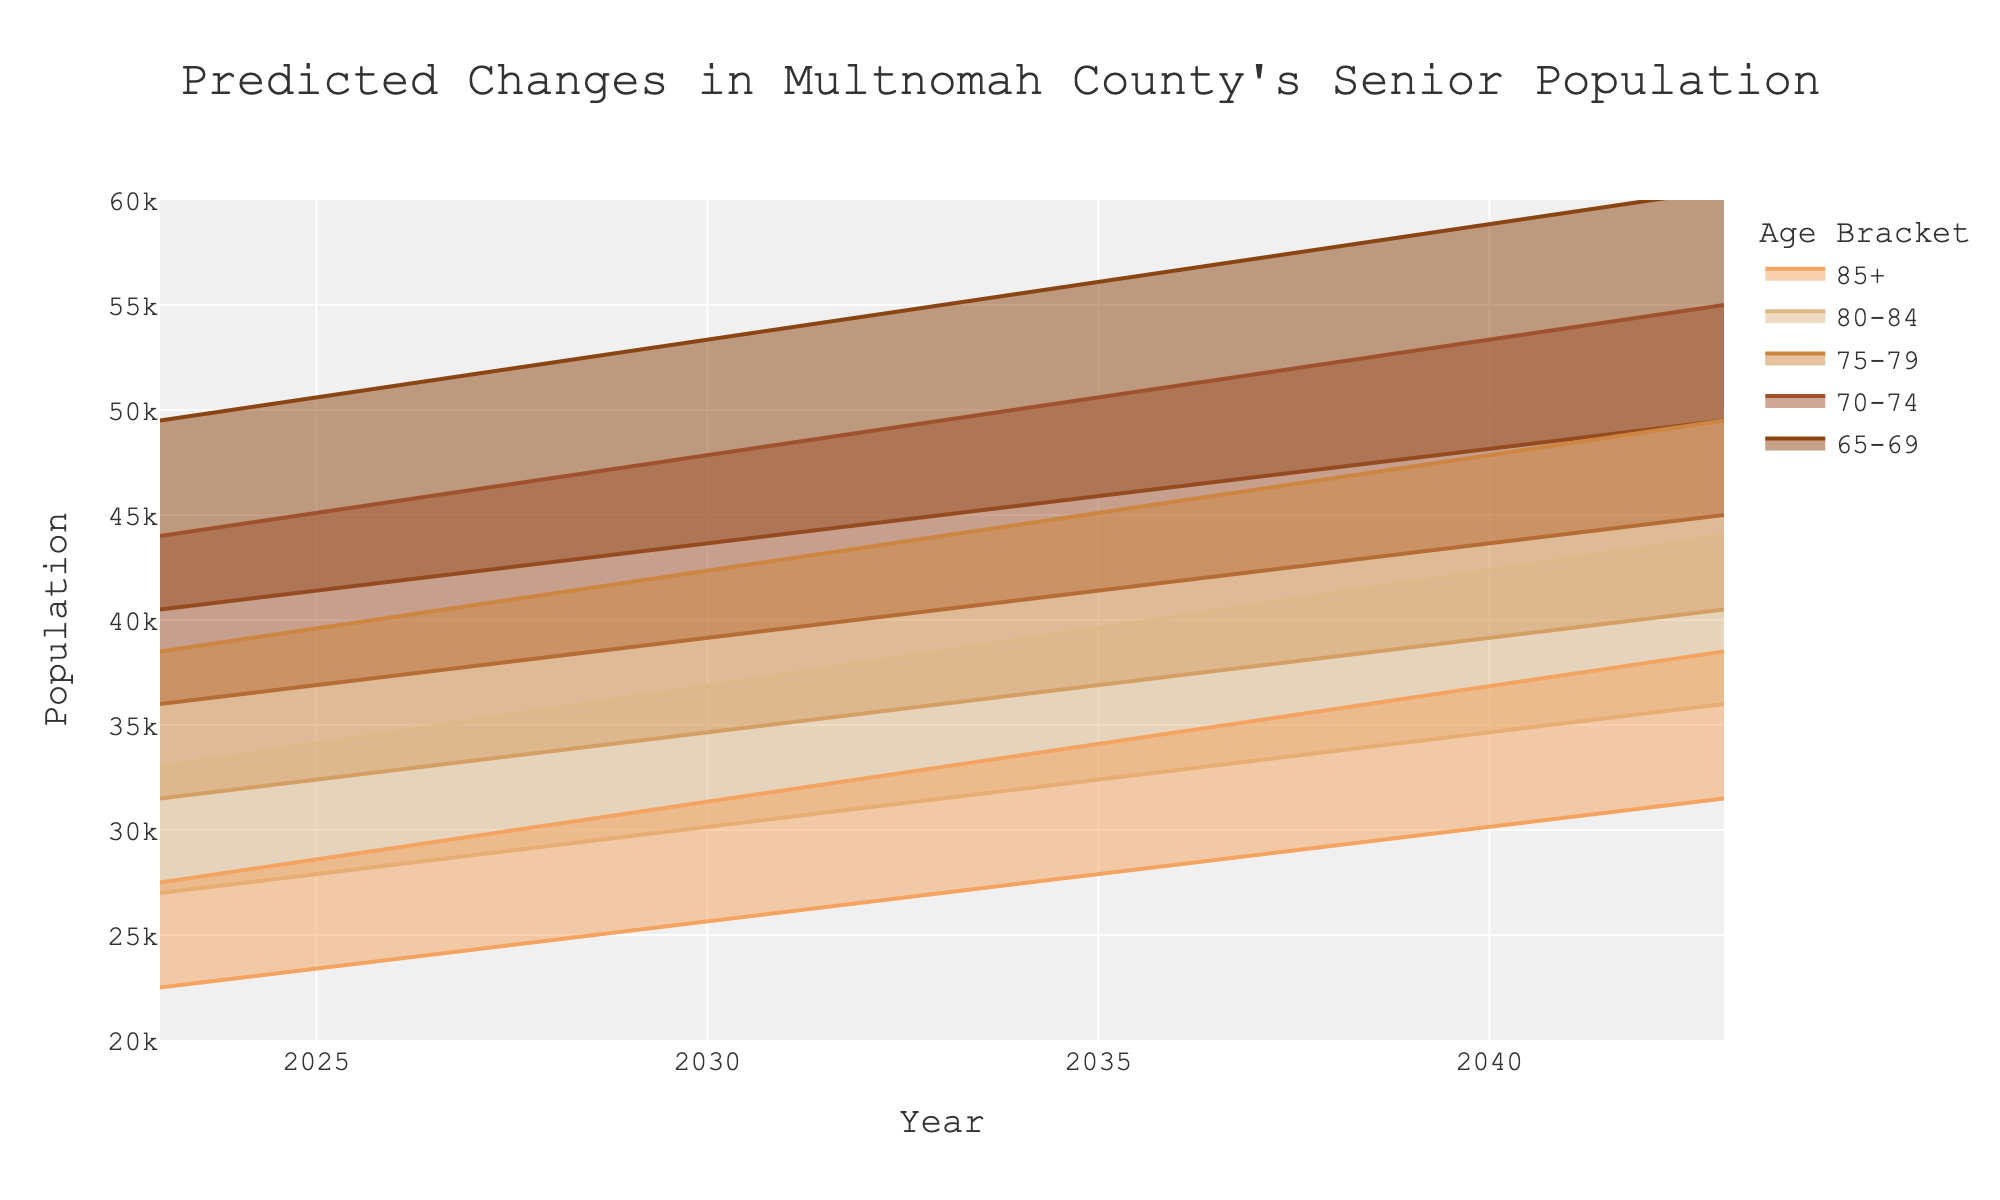What's the title of the figure? The title is displayed at the top center of the figure. It reads, "Predicted Changes in Multnomah County's Senior Population".
Answer: Predicted Changes in Multnomah County's Senior Population How many age brackets are shown in the figure? You can count the different lines or shaded areas representing each age bracket. There are five in total.
Answer: 5 What is the projected senior population for the age bracket 75-79 in the year 2033? Locate the "75-79" age bracket and follow the line to the year 2033 on the x-axis. The value at this point is 40,000.
Answer: 40,000 What is the range of the predicted population for the age bracket 65-69 in the year 2028? For the "65-69" age bracket in 2028, refer to the upper and lower bounds, which are 52,250 and 42,750 respectively. The range is the difference between these values.
Answer: 45,000 to 52,250 Which age bracket has the steepest increase in its upper bound from 2023 to 2043? Look at the lines representing the upper bounds of each age bracket and determine the one with the sharpest slope. The steepest increase in upper bound is observed in the "65-69" age bracket.
Answer: 65-69 What is the predicted senior population for the age bracket 85+ in 2043? Locate the line for the "85+" age bracket and follow it to the year 2043 on the x-axis. The value at this point is 35,000.
Answer: 35,000 Which age bracket has the narrowest prediction interval (smallest difference between upper and lower bounds) in 2033? Calculate the difference between the upper and lower bounds for each age bracket in 2033. The narrowest interval is for the "65-69" age bracket with values between 45,000 and 55,000.
Answer: 85+ In 2038, which age bracket is projected to have a lower bound incorrectly touching or crossing the 25,000 mark? Find the lower bounds for each age bracket in 2038. The age bracket "85+" is kissing the 25,000 mark.
Answer: 85+ By how much is the senior population for the age bracket 70-74 expected to increase from 2023 to 2038? Subtract the 2023 value from the 2038 value for the age bracket "70-74". The expected population increase is 47,500 - 40,000, which equals 7,500.
Answer: 7,500 